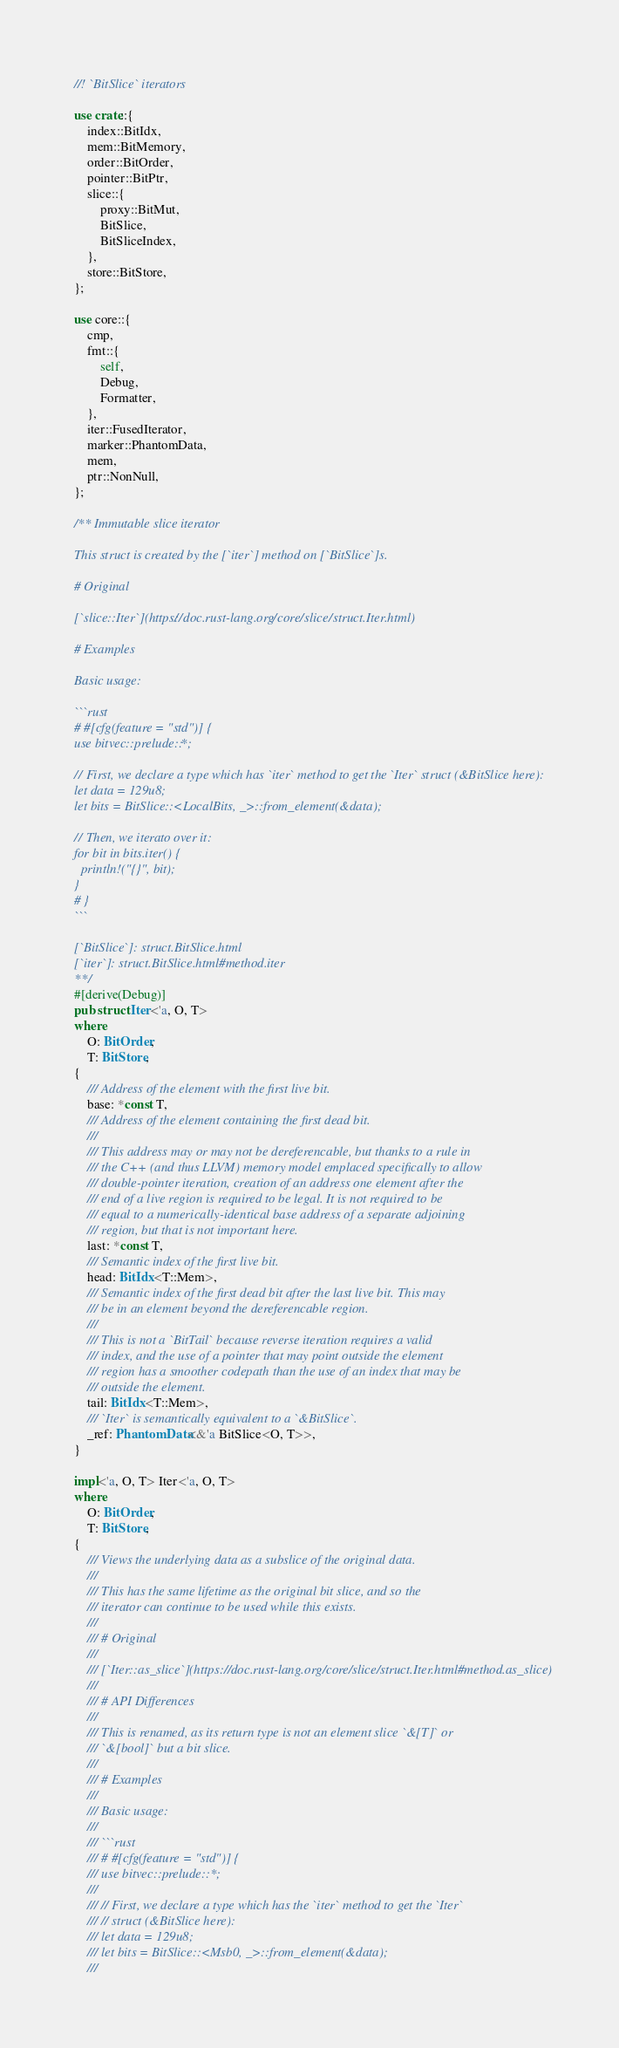<code> <loc_0><loc_0><loc_500><loc_500><_Rust_>//! `BitSlice` iterators

use crate::{
	index::BitIdx,
	mem::BitMemory,
	order::BitOrder,
	pointer::BitPtr,
	slice::{
		proxy::BitMut,
		BitSlice,
		BitSliceIndex,
	},
	store::BitStore,
};

use core::{
	cmp,
	fmt::{
		self,
		Debug,
		Formatter,
	},
	iter::FusedIterator,
	marker::PhantomData,
	mem,
	ptr::NonNull,
};

/** Immutable slice iterator

This struct is created by the [`iter`] method on [`BitSlice`]s.

# Original

[`slice::Iter`](https://doc.rust-lang.org/core/slice/struct.Iter.html)

# Examples

Basic usage:

```rust
# #[cfg(feature = "std")] {
use bitvec::prelude::*;

// First, we declare a type which has `iter` method to get the `Iter` struct (&BitSlice here):
let data = 129u8;
let bits = BitSlice::<LocalBits, _>::from_element(&data);

// Then, we iterato over it:
for bit in bits.iter() {
  println!("{}", bit);
}
# }
```

[`BitSlice`]: struct.BitSlice.html
[`iter`]: struct.BitSlice.html#method.iter
**/
#[derive(Debug)]
pub struct Iter<'a, O, T>
where
	O: BitOrder,
	T: BitStore,
{
	/// Address of the element with the first live bit.
	base: *const T,
	/// Address of the element containing the first dead bit.
	///
	/// This address may or may not be dereferencable, but thanks to a rule in
	/// the C++ (and thus LLVM) memory model emplaced specifically to allow
	/// double-pointer iteration, creation of an address one element after the
	/// end of a live region is required to be legal. It is not required to be
	/// equal to a numerically-identical base address of a separate adjoining
	/// region, but that is not important here.
	last: *const T,
	/// Semantic index of the first live bit.
	head: BitIdx<T::Mem>,
	/// Semantic index of the first dead bit after the last live bit. This may
	/// be in an element beyond the dereferencable region.
	///
	/// This is not a `BitTail` because reverse iteration requires a valid
	/// index, and the use of a pointer that may point outside the element
	/// region has a smoother codepath than the use of an index that may be
	/// outside the element.
	tail: BitIdx<T::Mem>,
	/// `Iter` is semantically equivalent to a `&BitSlice`.
	_ref: PhantomData<&'a BitSlice<O, T>>,
}

impl<'a, O, T> Iter<'a, O, T>
where
	O: BitOrder,
	T: BitStore,
{
	/// Views the underlying data as a subslice of the original data.
	///
	/// This has the same lifetime as the original bit slice, and so the
	/// iterator can continue to be used while this exists.
	///
	/// # Original
	///
	/// [`Iter::as_slice`](https://doc.rust-lang.org/core/slice/struct.Iter.html#method.as_slice)
	///
	/// # API Differences
	///
	/// This is renamed, as its return type is not an element slice `&[T]` or
	/// `&[bool]` but a bit slice.
	///
	/// # Examples
	///
	/// Basic usage:
	///
	/// ```rust
	/// # #[cfg(feature = "std")] {
	/// use bitvec::prelude::*;
	///
	/// // First, we declare a type which has the `iter` method to get the `Iter`
	/// // struct (&BitSlice here):
	/// let data = 129u8;
	/// let bits = BitSlice::<Msb0, _>::from_element(&data);
	///</code> 